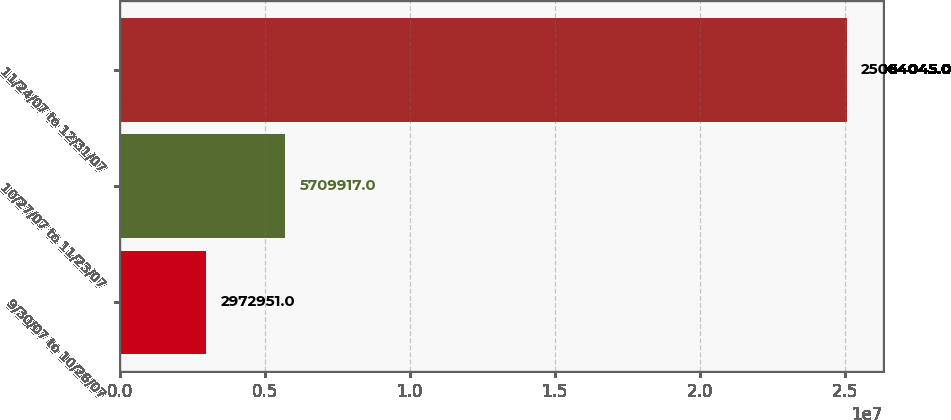Convert chart. <chart><loc_0><loc_0><loc_500><loc_500><bar_chart><fcel>9/30/07 to 10/26/07<fcel>10/27/07 to 11/23/07<fcel>11/24/07 to 12/31/07<nl><fcel>2.97295e+06<fcel>5.70992e+06<fcel>2.5064e+07<nl></chart> 